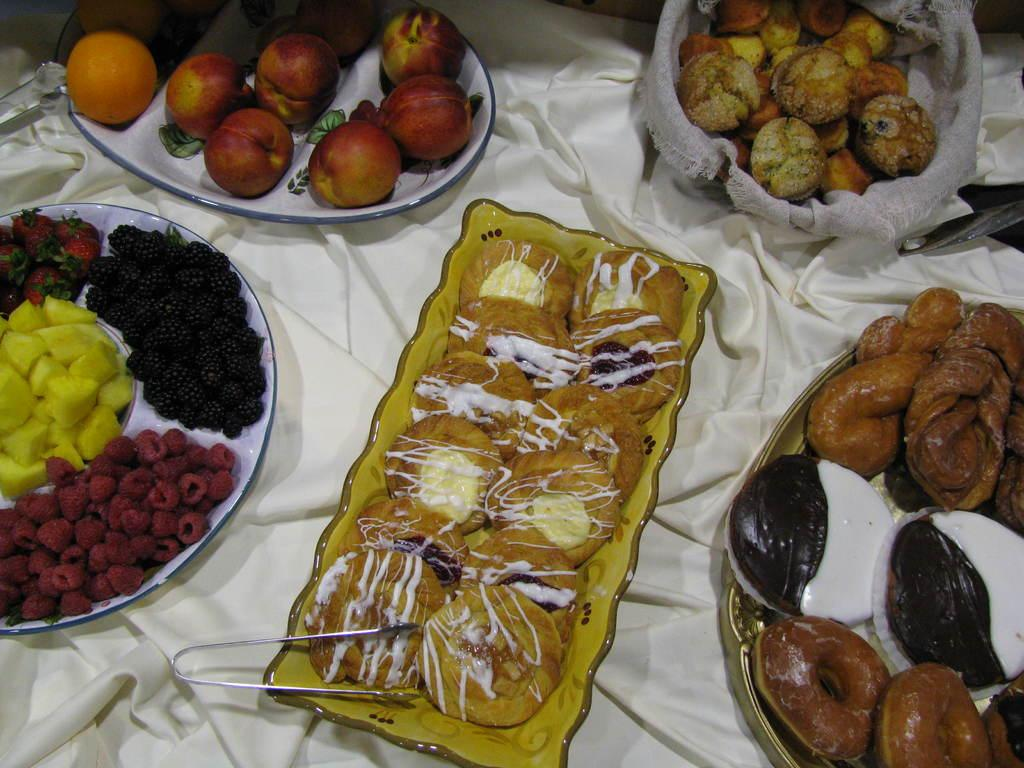What is on the plates that are visible in the image? There are eatable items on plates in the image. Where are the plates located in the image? The plates are on a table in the image. What type of objects can be seen in the image besides the plates and eatable items? There are metal objects visible in the image. What type of sign can be seen near the river in the image? There is no sign or river present in the image; it only features plates with eatable items on a table and metal objects. 